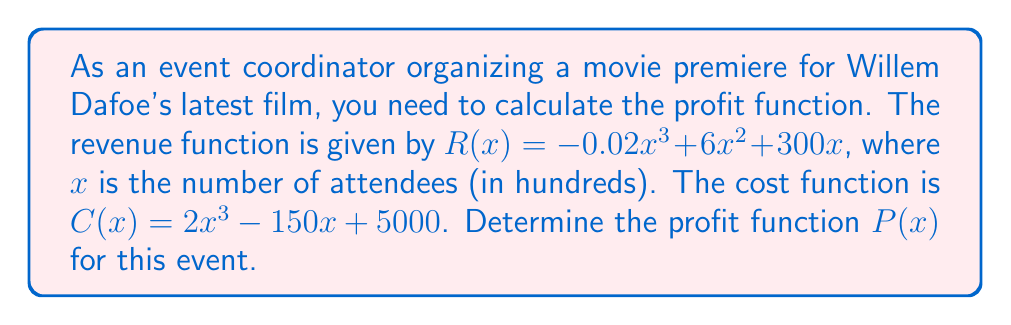Can you answer this question? To calculate the profit function, we need to follow these steps:

1. Recall that profit is the difference between revenue and cost:
   $P(x) = R(x) - C(x)$

2. We are given:
   Revenue function: $R(x) = -0.02x^3 + 6x^2 + 300x$
   Cost function: $C(x) = 2x^3 - 150x + 5000$

3. Substitute these into the profit equation:
   $P(x) = (-0.02x^3 + 6x^2 + 300x) - (2x^3 - 150x + 5000)$

4. Distribute the negative sign to the cost function:
   $P(x) = -0.02x^3 + 6x^2 + 300x - 2x^3 + 150x - 5000$

5. Combine like terms:
   $P(x) = (-0.02x^3 - 2x^3) + 6x^2 + (300x + 150x) - 5000$
   $P(x) = -2.02x^3 + 6x^2 + 450x - 5000$

Therefore, the profit function $P(x)$ is a cubic polynomial.
Answer: $P(x) = -2.02x^3 + 6x^2 + 450x - 5000$ 